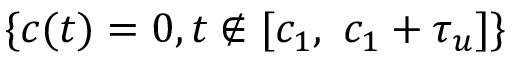<formula> <loc_0><loc_0><loc_500><loc_500>\{ c ( t ) = 0 , t \not \in [ c _ { 1 } , \ c _ { 1 } + \tau _ { u } ] \}</formula> 